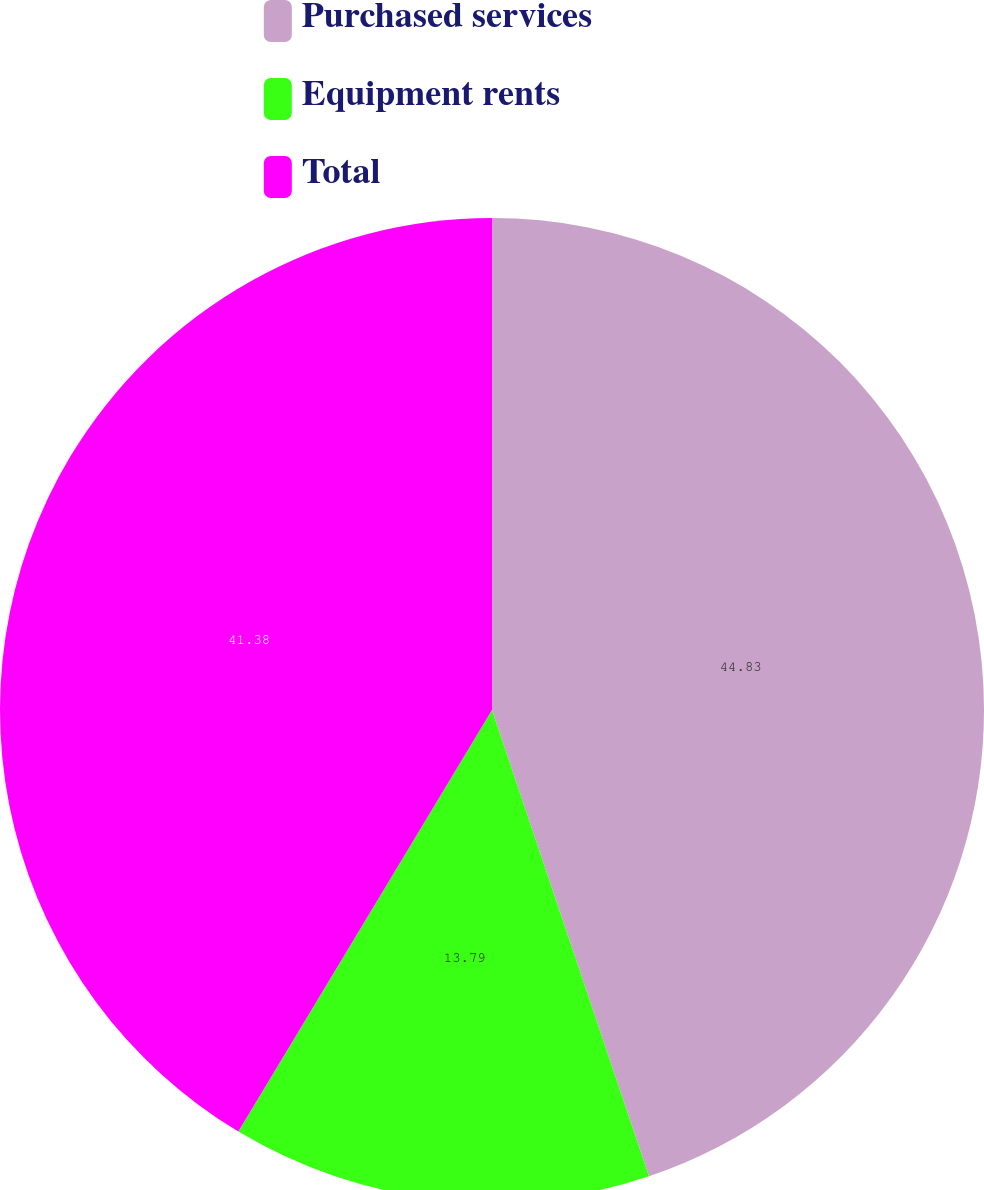Convert chart to OTSL. <chart><loc_0><loc_0><loc_500><loc_500><pie_chart><fcel>Purchased services<fcel>Equipment rents<fcel>Total<nl><fcel>44.83%<fcel>13.79%<fcel>41.38%<nl></chart> 